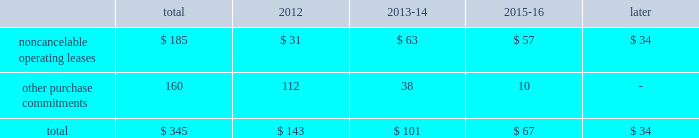2322 t .
R o w e p r i c e g r o u p a n n u a l r e p o r t 2 0 1 1 c o n t r a c t u a l o b l i g at i o n s the table presents a summary of our future obligations ( in a0millions ) under the terms of existing operating leases and other contractual cash purchase commitments at december 31 , 2011 .
Other purchase commitments include contractual amounts that will be due for the purchase of goods or services to be used in our operations and may be cancelable at earlier times than those indicated , under certain conditions that may involve termination fees .
Because these obligations are generally of a normal recurring nature , we expect that we will fund them from future cash flows from operations .
The information presented does not include operating expenses or capital expenditures that will be committed in the normal course of operations in 2012 and future years .
The information also excludes the $ 4.7 a0million of uncertain tax positions discussed in note 9 to our consolidated financial statements because it is not possible to estimate the time period in which a payment might be made to the tax authorities. .
We also have outstanding commitments to fund additional contributions to investment partnerships in which we have an existing investment totaling $ 42.5 a0million at december 31 , 2011 .
C r i t i c a l a c c o u n t i n g p o l i c i e s the preparation of financial statements often requires the selection of specific accounting methods and policies from among several acceptable alternatives .
Further , significant estimates and judgments may be required in selecting and applying those methods and policies in the recognition of the assets and liabilities in our balance sheet , the revenues and expenses in our statement of income , and the information that is contained in our significant accounting policies and notes to consolidated financial statements .
Making these estimates and judgments requires the analysis of information concerning events that may not yet be complete and of facts and circumstances that may change over time .
Accordingly , actual amounts or future results can differ materially from those estimates that we include currently in our consolidated financial statements , significant accounting policies , and notes .
We present those significant accounting policies used in the preparation of our consolidated financial statements as an integral part of those statements within this 2011 annual report .
In the following discussion , we highlight and explain further certain of those policies that are most critical to the preparation and understanding of our financial statements .
Other than temporary impairments of available-for-sale securities .
We generally classify our investment holdings in sponsored mutual funds and the debt securities held for investment by our savings bank subsidiary as available-for-sale .
At the end of each quarter , we mark the carrying amount of each investment holding to fair value and recognize an unrealized gain or loss as a component of comprehensive income within the statement of stockholders 2019 equity .
We next review each individual security position that has an unrealized loss or impairment to determine if that impairment is other than temporary .
In determining whether a mutual fund holding is other than temporarily impaired , we consider many factors , including the duration of time it has existed , the severity of the impairment , any subsequent changes in value , and our intent and ability to hold the security for a period of time sufficient for an anticipated recovery in fair value .
Subject to the other considerations noted above , with respect to duration of time , we believe a mutual fund holding with an unrealized loss that has persisted daily throughout the six months between quarter-ends is generally presumed to have an other than temporary impairment .
We may also recognize an other than temporary loss of less than six months in our statement of income if the particular circumstances of the underlying investment do not warrant our belief that a near-term recovery is possible .
An impaired debt security held by our savings bank subsidiary is considered to have an other than temporary loss that we will recognize in our statement of income if the impairment is caused by a change in credit quality that affects our ability to recover our amortized cost or if we intend to sell the security or believe that it is more likely than not that we will be required to sell the security before recovering cost .
Minor impairments of 5% ( 5 % ) or less are generally considered temporary .
Other than temporary impairments of equity method investments .
We evaluate our equity method investments , including our investment in uti , for impairment when events or changes in circumstances indicate that the carrying value of the investment exceeds its fair value , and the decline in fair value is other than temporary .
Goodwill .
We internally conduct , manage and report our operations as one investment advisory business .
We do not have distinct operating segments or components that separately constitute a business .
Accordingly , we attribute goodwill to a single reportable business segment and reporting unit 2014our investment advisory business .
We evaluate the carrying amount of goodwill in our balance sheet for possible impairment on an annual basis in the third quarter of each year using a fair value approach .
Goodwill would be considered impaired whenever our historical carrying amount exceeds the fair value of our investment advisory business .
Our annual testing has demonstrated that the fair value of our investment advisory business ( our market capitalization ) exceeds our carrying amount ( our stockholders 2019 equity ) and , therefore , no impairment exists .
Should we reach a different conclusion in the future , additional work would be performed to ascertain the amount of the non-cash impairment charge to be recognized .
We must also perform impairment testing at other times if an event or circumstance occurs indicating that it is more likely than not that an impairment has been incurred .
The maximum future impairment of goodwill that we could incur is the amount recognized in our balance sheet , $ 665.7 a0million .
Stock options .
We recognize stock option-based compensation expense in our consolidated statement of income using a fair value based method .
Fair value methods use a valuation model for shorter-term , market-traded financial instruments to theoretically value stock option grants even though they are not available for trading and are of longer duration .
The black- scholes option-pricing model that we use includes the input of certain variables that are dependent on future expectations , including the expected lives of our options from grant date to exercise date , the volatility of our underlying common shares in the market over that time period , and the rate of dividends that we will pay during that time .
Our estimates of these variables are made for the purpose of using the valuation model to determine an expense for each reporting period and are not subsequently adjusted .
Unlike most of our expenses , the resulting charge to earnings using a fair value based method is a non-cash charge that is never measured by , or adjusted based on , a cash outflow .
Provision for income taxes .
After compensation and related costs , our provision for income taxes on our earnings is our largest annual expense .
We operate in numerous states and countries through our various subsidiaries , and must allocate our income , expenses , and earnings under the various laws and regulations of each of these taxing jurisdictions .
Accordingly , our provision for income taxes represents our total estimate of the liability that we have incurred in doing business each year in all of our locations .
Annually , we file tax returns that represent our filing positions with each jurisdiction and settle our return liabilities .
Each jurisdiction has the right to audit those returns and may take different positions with respect to income and expense allocations and taxable earnings determinations .
From time to time , we may also provide for estimated liabilities associated with uncertain tax return filing positions that are subject to , or in the process of , being audited by various tax authorities .
Because the determination of our annual provision is subject to judgments and estimates , it is likely that actual results will vary from those recognized in our financial statements .
As a result , we recognize additions to , or reductions of , income tax expense during a reporting period that pertain to prior period provisions as our estimated liabilities are revised and actual tax returns and tax audits are settled .
We recognize any such prior period adjustment in the discrete quarterly period in which it is determined .
N e w ly i s s u e d b u t n o t y e t a d o p t e d a c c o u n t i n g g u i d a n c e in may 2011 , the fasb issued amended guidance clarifying how to measure and disclose fair value .
We do not believe the adoption of such amended guidance on january 1 , 2012 , will have a significant effect on our consolidated financial statements .
We have also considered all other newly issued accounting guidance that is applicable to our operations and the preparation of our consolidated statements , including that which we have not yet adopted .
We do not believe that any such guidance will have a material effect on our financial position or results of operation. .
What percentage of total other purchase commitments is made up of noncancelable operating leases? 
Computations: (185 / 345)
Answer: 0.53623. 